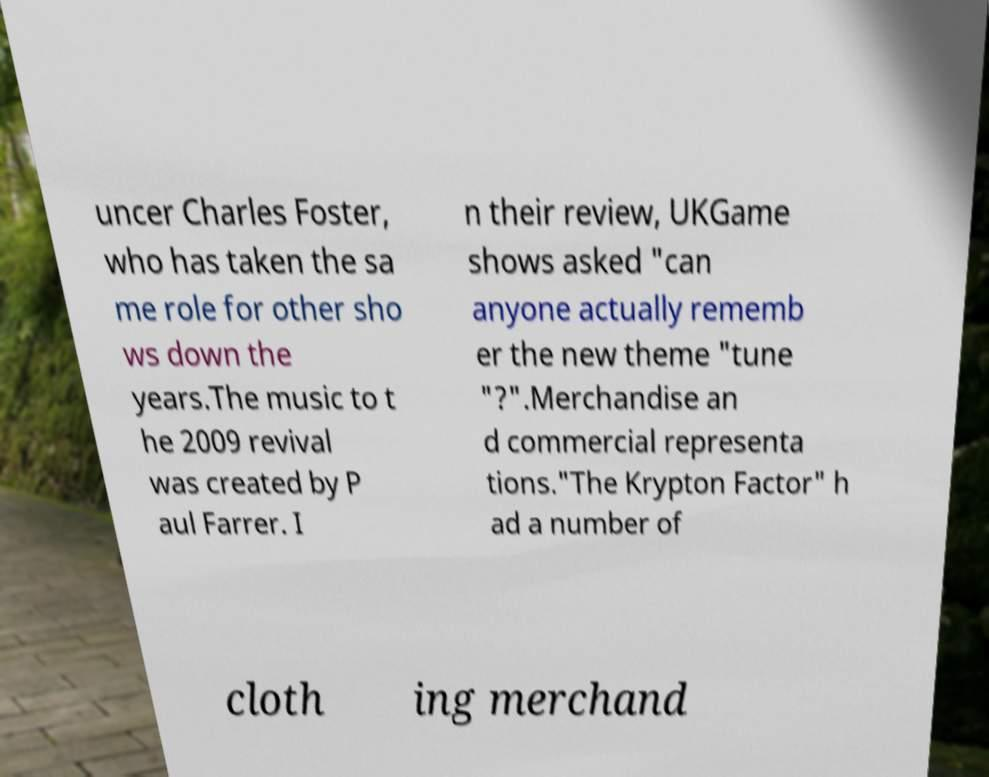Could you assist in decoding the text presented in this image and type it out clearly? uncer Charles Foster, who has taken the sa me role for other sho ws down the years.The music to t he 2009 revival was created by P aul Farrer. I n their review, UKGame shows asked "can anyone actually rememb er the new theme "tune "?".Merchandise an d commercial representa tions."The Krypton Factor" h ad a number of cloth ing merchand 